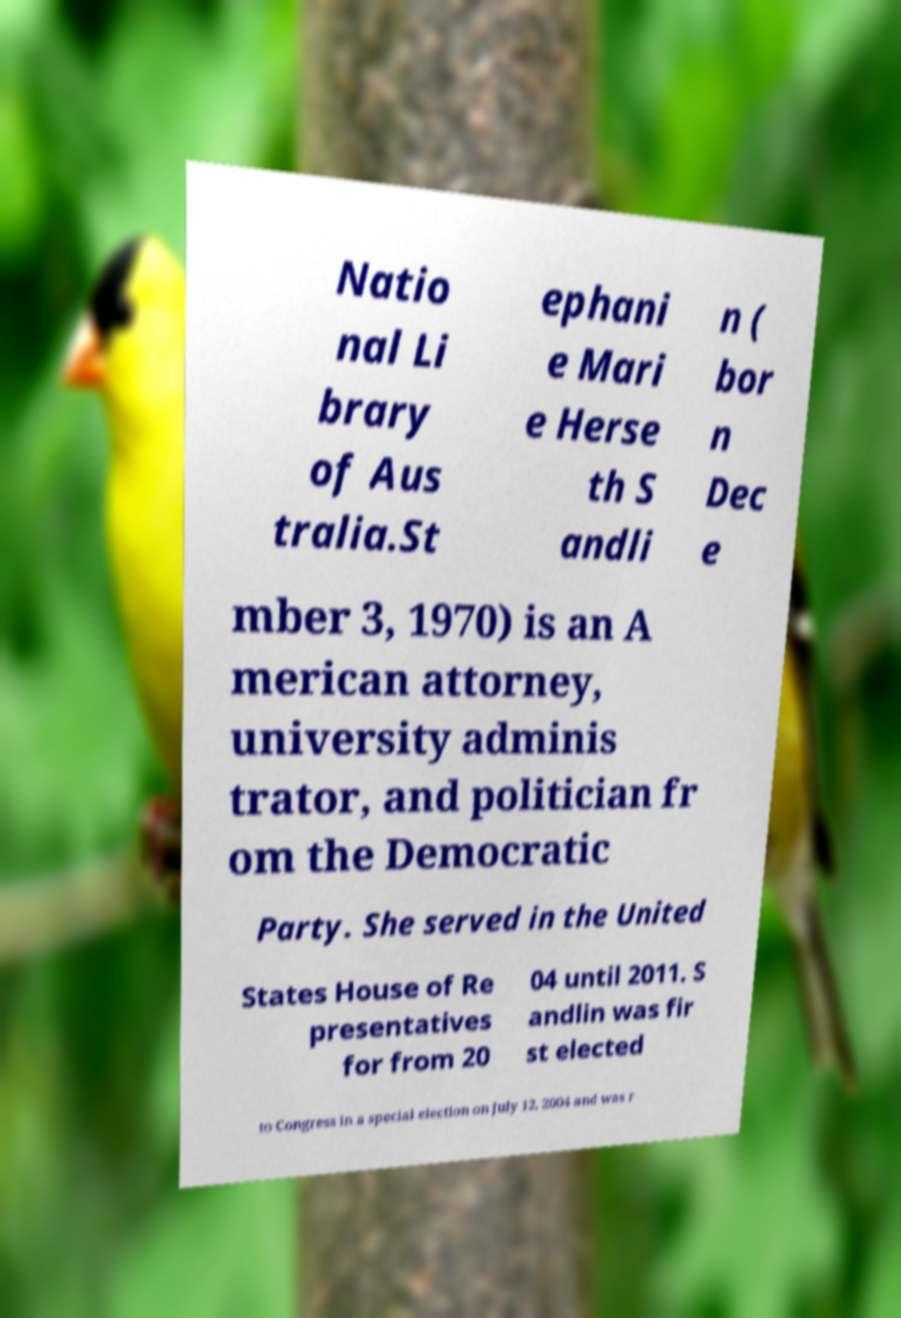Could you extract and type out the text from this image? Natio nal Li brary of Aus tralia.St ephani e Mari e Herse th S andli n ( bor n Dec e mber 3, 1970) is an A merican attorney, university adminis trator, and politician fr om the Democratic Party. She served in the United States House of Re presentatives for from 20 04 until 2011. S andlin was fir st elected to Congress in a special election on July 12, 2004 and was r 